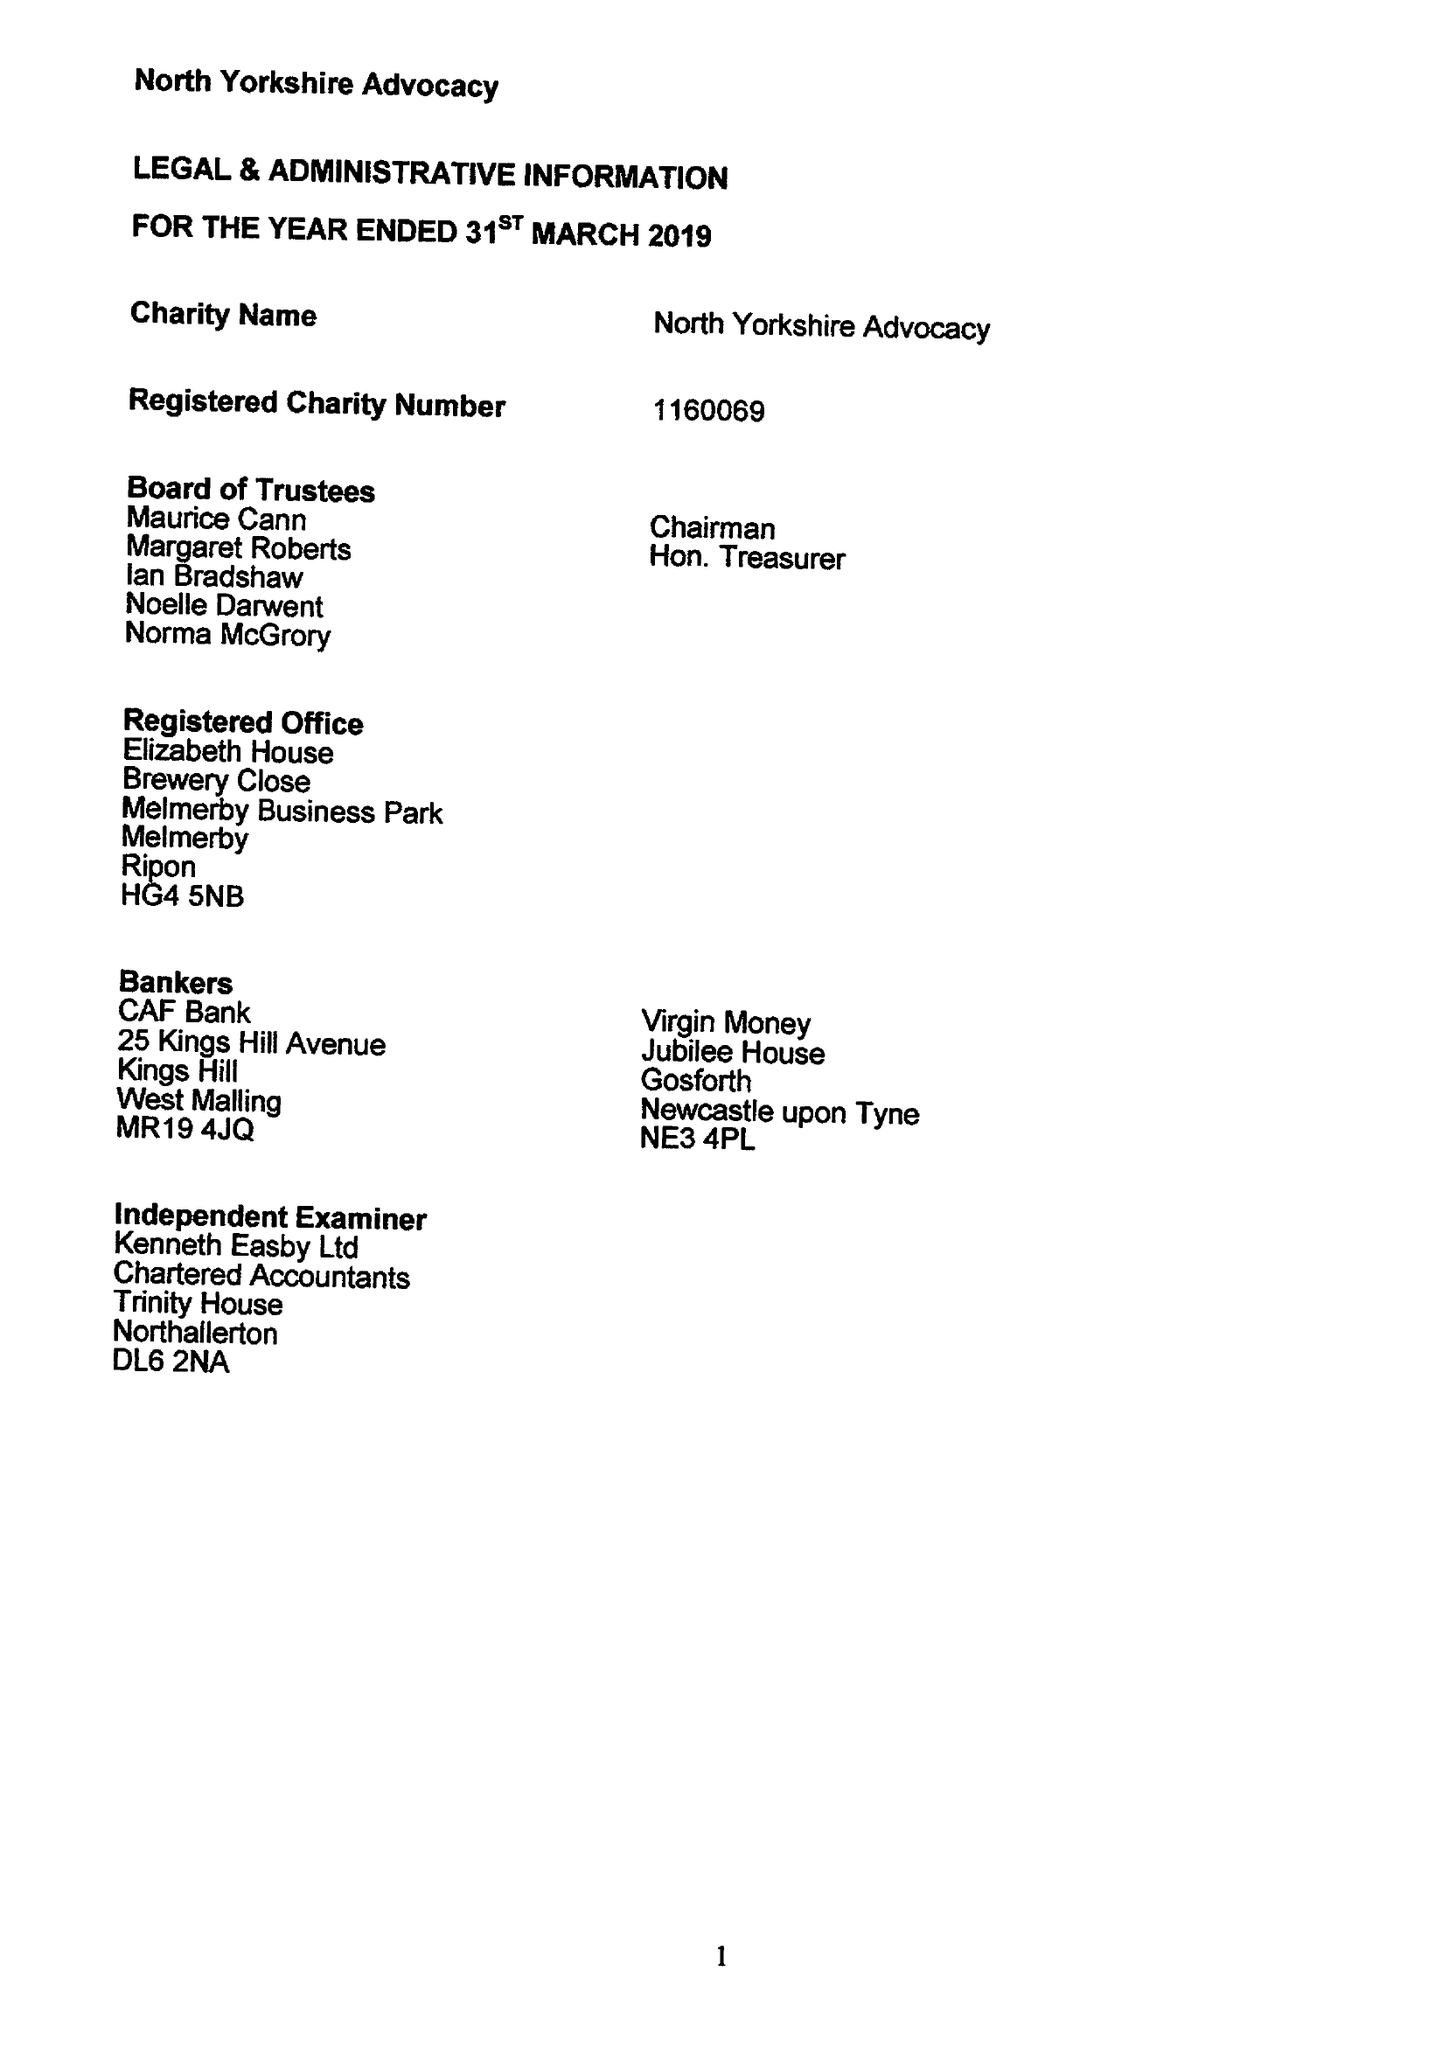What is the value for the income_annually_in_british_pounds?
Answer the question using a single word or phrase. 97788.00 